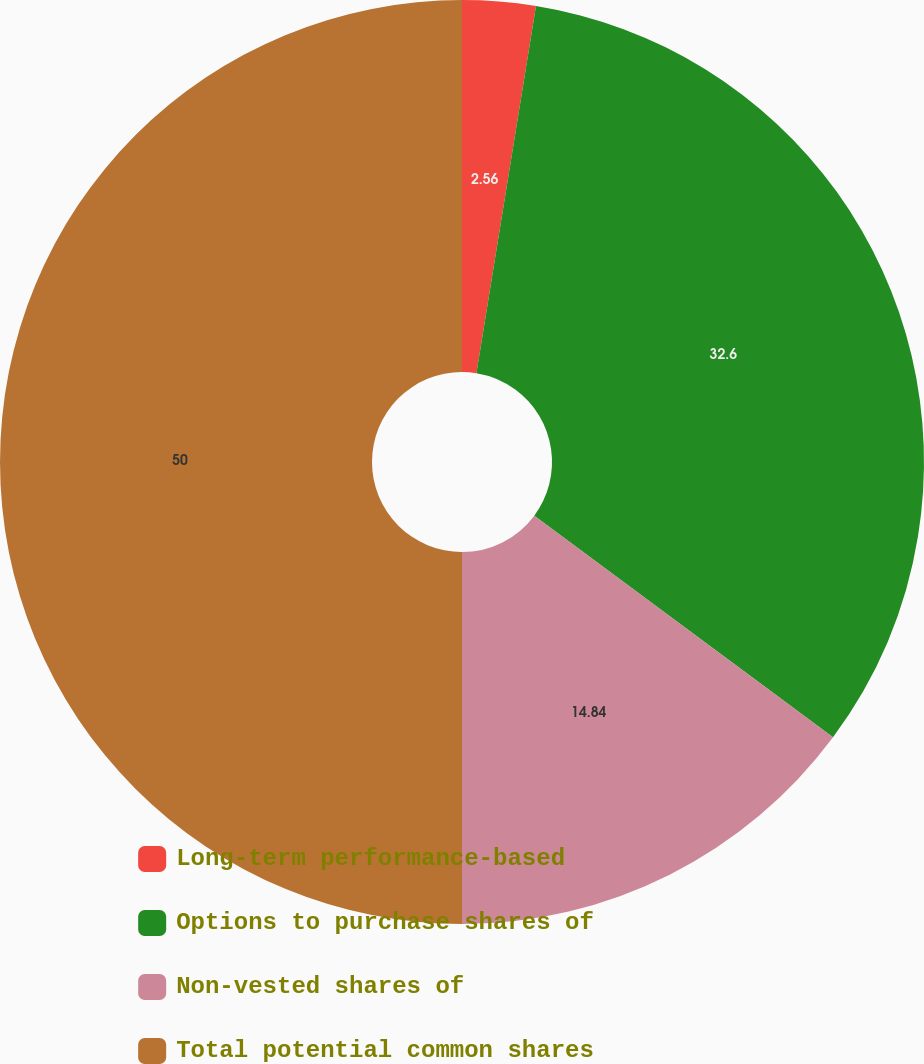Convert chart to OTSL. <chart><loc_0><loc_0><loc_500><loc_500><pie_chart><fcel>Long-term performance-based<fcel>Options to purchase shares of<fcel>Non-vested shares of<fcel>Total potential common shares<nl><fcel>2.56%<fcel>32.6%<fcel>14.84%<fcel>50.0%<nl></chart> 